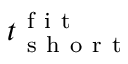Convert formula to latex. <formula><loc_0><loc_0><loc_500><loc_500>t _ { s h o r t } ^ { f i t }</formula> 